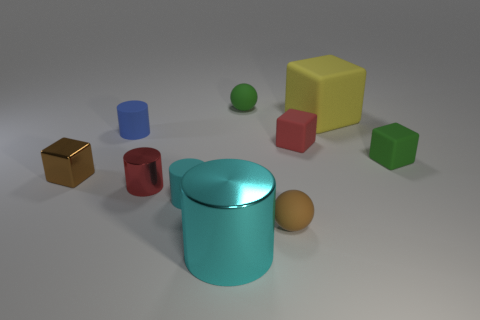Subtract all cyan cylinders. How many were subtracted if there are1cyan cylinders left? 1 Subtract 1 blocks. How many blocks are left? 3 Subtract all cylinders. How many objects are left? 6 Add 5 blue rubber objects. How many blue rubber objects exist? 6 Subtract 1 red cubes. How many objects are left? 9 Subtract all big brown metal things. Subtract all tiny metallic cylinders. How many objects are left? 9 Add 4 tiny balls. How many tiny balls are left? 6 